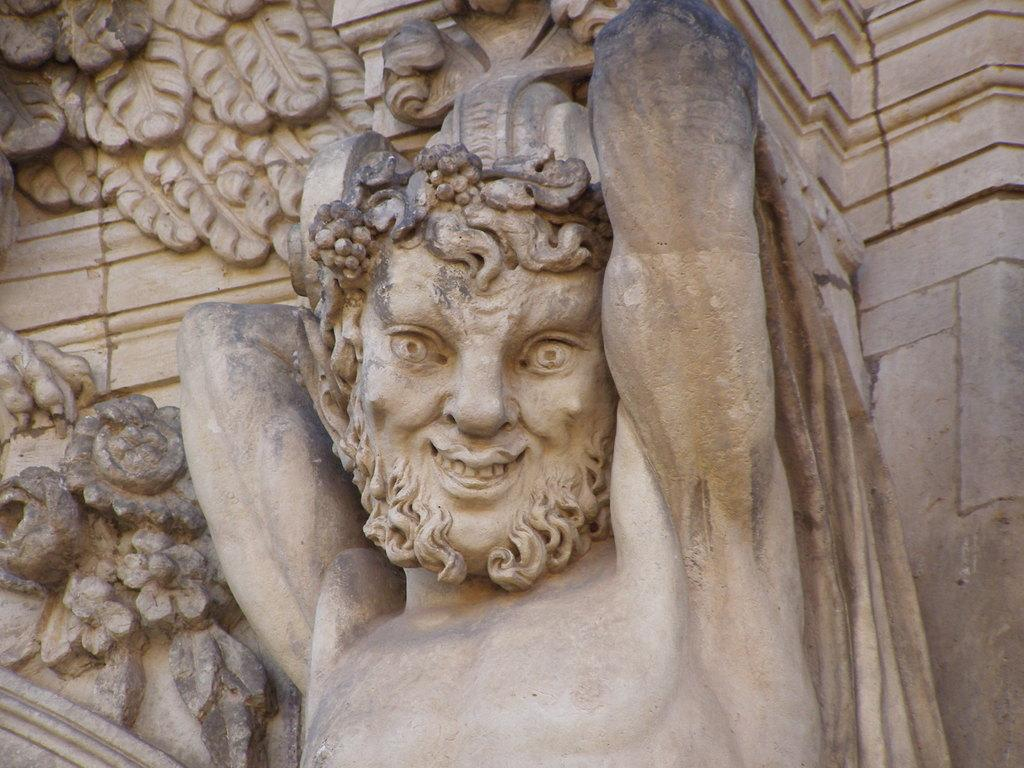What is the main subject in the image? There is a sculpture in the image. Where is the sculpture located? The sculpture is on a wall. Can you see a nest made of sleet in the image? There is no nest or sleet present in the image. What type of ink is used to create the sculpture in the image? The image does not provide information about the materials or techniques used to create the sculpture. 